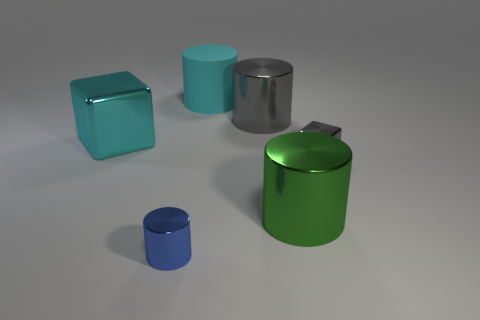Subtract all purple cylinders. Subtract all purple cubes. How many cylinders are left? 4 Add 3 tiny gray blocks. How many objects exist? 9 Subtract all cylinders. How many objects are left? 2 Add 4 big cyan rubber cylinders. How many big cyan rubber cylinders are left? 5 Add 2 big cyan matte objects. How many big cyan matte objects exist? 3 Subtract 0 purple cylinders. How many objects are left? 6 Subtract all large green cylinders. Subtract all big cyan things. How many objects are left? 3 